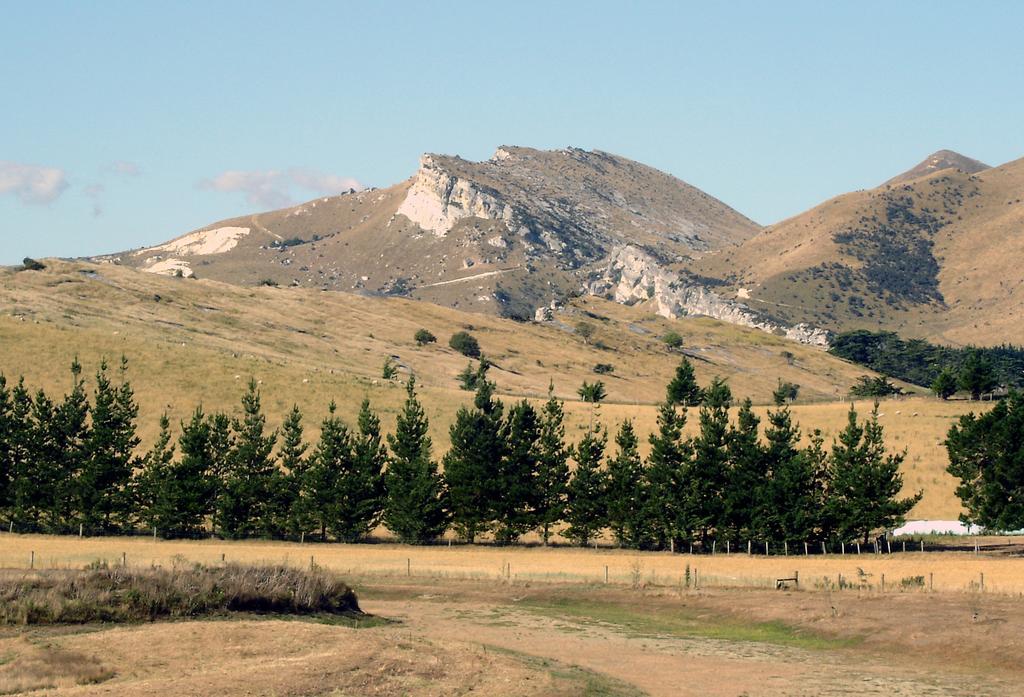Describe this image in one or two sentences. In the foreground of the picture there are shrubs, fencing and a land. In the center of the picture there are trees, grass and a mountain. Sky is sunny. 